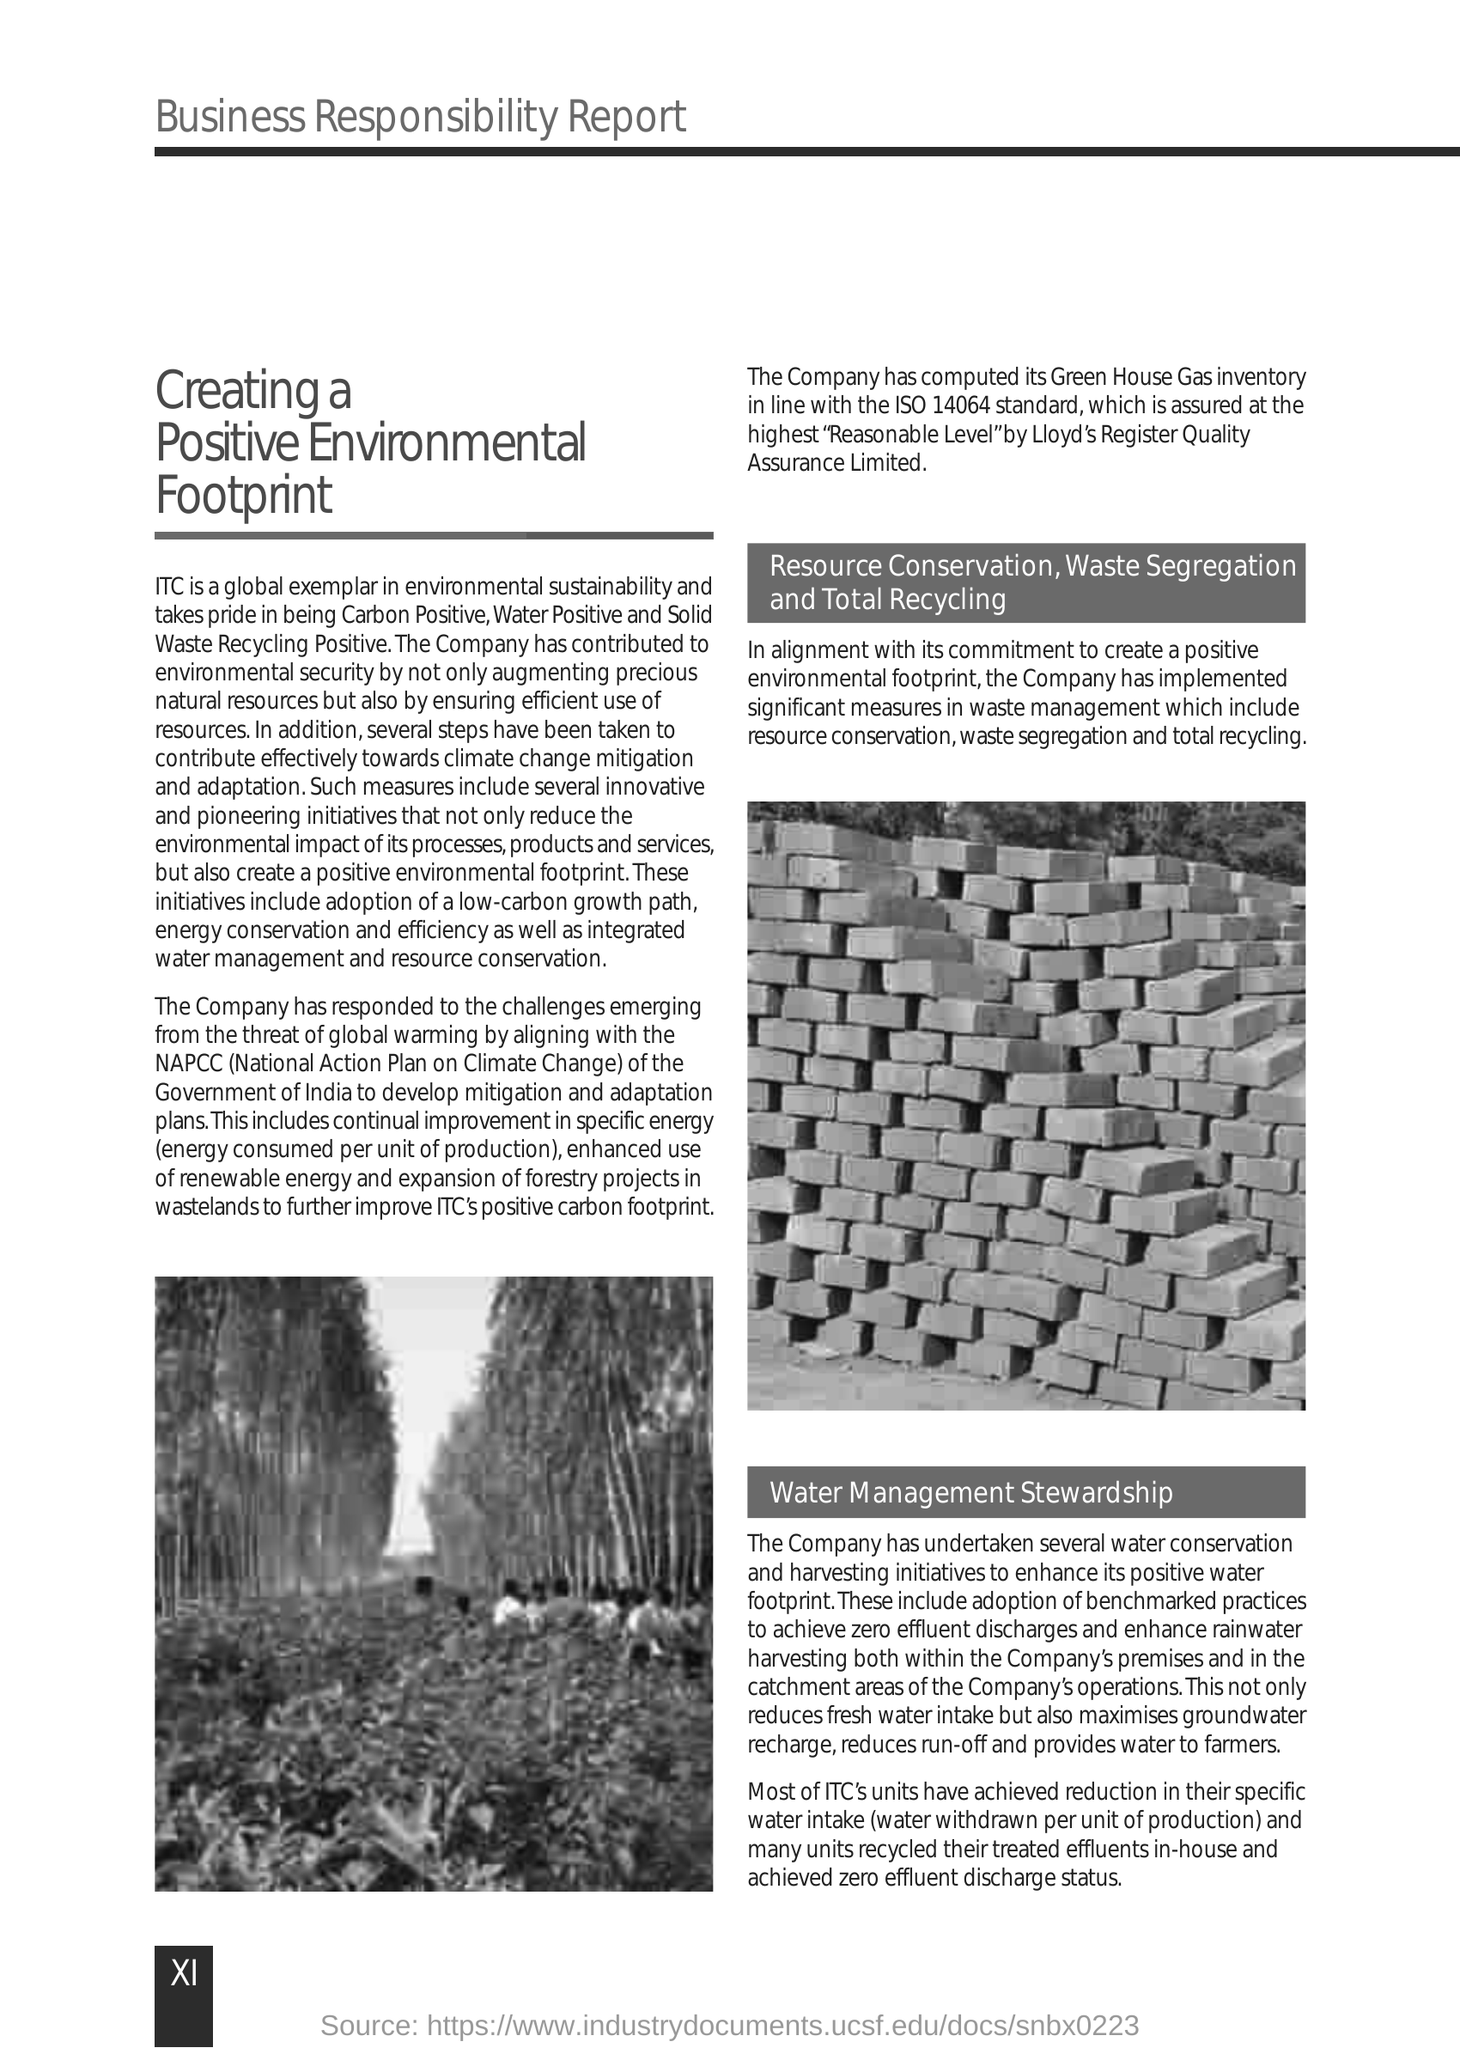What does NAPCC stand for?
Give a very brief answer. National Action Plan on Climate Change. What is specific energy?
Keep it short and to the point. Energy consumed per unit of production. What is specific water intake?
Provide a short and direct response. Water withdrawn per unit of production. In line with which standard has the Company computed its Green House Gas inventory?
Provide a short and direct response. ISO 14064. 